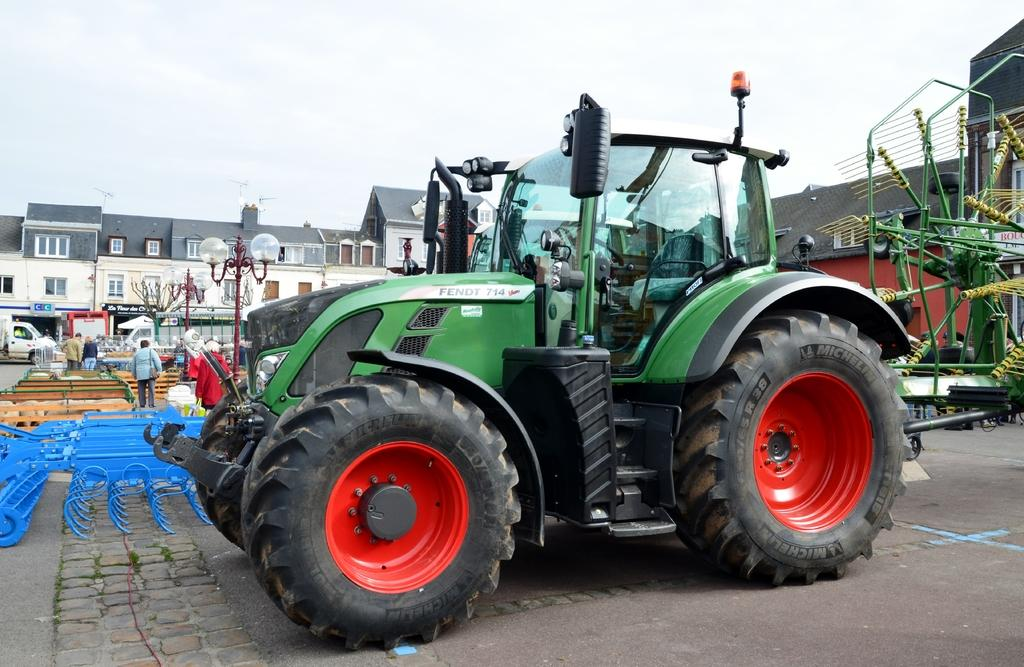What types of objects can be seen in the image? There are vehicles, a fence, people, poles, boards, lights, buildings, and a few unspecified objects in the image. Can you describe the setting of the image? The image features vehicles, a fence, people, poles, boards, lights, and buildings, which suggests an urban or city environment. The sky is visible in the background of the image. What might the unspecified objects be? Without more information, it is difficult to determine the nature of the unspecified objects in the image. Are there any sources of illumination in the image? Yes, there are lights in the image. What type of doctor is seen writing a prescription in the image? There is no doctor or prescription present in the image. What effect does the writing have on the vehicles in the image? There is no writing present in the image, so it cannot have any effect on the vehicles. 